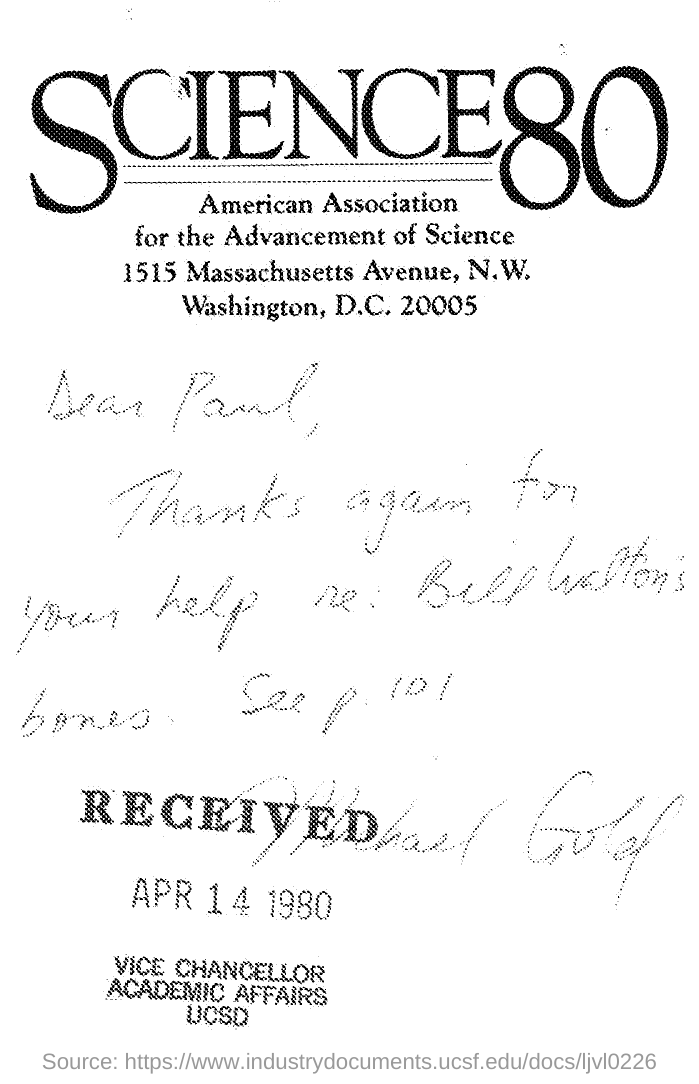Indicate a few pertinent items in this graphic. To whom this was sent is Paul. 